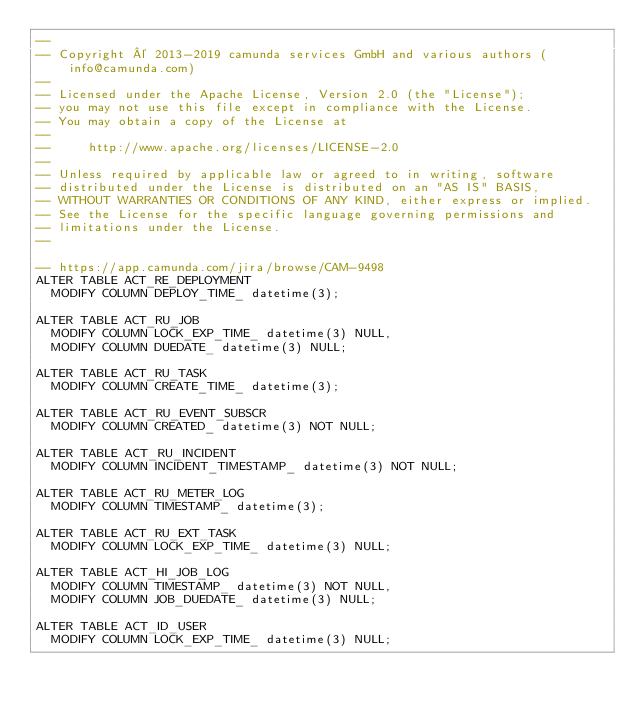<code> <loc_0><loc_0><loc_500><loc_500><_SQL_>--
-- Copyright © 2013-2019 camunda services GmbH and various authors (info@camunda.com)
--
-- Licensed under the Apache License, Version 2.0 (the "License");
-- you may not use this file except in compliance with the License.
-- You may obtain a copy of the License at
--
--     http://www.apache.org/licenses/LICENSE-2.0
--
-- Unless required by applicable law or agreed to in writing, software
-- distributed under the License is distributed on an "AS IS" BASIS,
-- WITHOUT WARRANTIES OR CONDITIONS OF ANY KIND, either express or implied.
-- See the License for the specific language governing permissions and
-- limitations under the License.
--

-- https://app.camunda.com/jira/browse/CAM-9498
ALTER TABLE ACT_RE_DEPLOYMENT
  MODIFY COLUMN DEPLOY_TIME_ datetime(3);

ALTER TABLE ACT_RU_JOB
  MODIFY COLUMN LOCK_EXP_TIME_ datetime(3) NULL,
  MODIFY COLUMN DUEDATE_ datetime(3) NULL;

ALTER TABLE ACT_RU_TASK
  MODIFY COLUMN CREATE_TIME_ datetime(3);

ALTER TABLE ACT_RU_EVENT_SUBSCR
  MODIFY COLUMN CREATED_ datetime(3) NOT NULL;

ALTER TABLE ACT_RU_INCIDENT
  MODIFY COLUMN INCIDENT_TIMESTAMP_ datetime(3) NOT NULL;

ALTER TABLE ACT_RU_METER_LOG
  MODIFY COLUMN TIMESTAMP_ datetime(3);

ALTER TABLE ACT_RU_EXT_TASK
  MODIFY COLUMN LOCK_EXP_TIME_ datetime(3) NULL;

ALTER TABLE ACT_HI_JOB_LOG
  MODIFY COLUMN TIMESTAMP_ datetime(3) NOT NULL,
  MODIFY COLUMN JOB_DUEDATE_ datetime(3) NULL;

ALTER TABLE ACT_ID_USER
  MODIFY COLUMN LOCK_EXP_TIME_ datetime(3) NULL;
</code> 